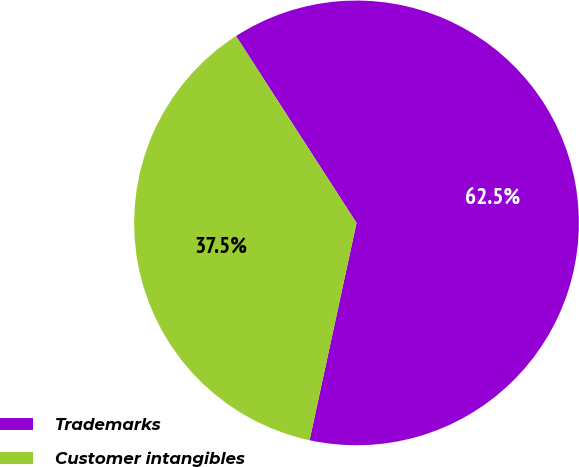Convert chart. <chart><loc_0><loc_0><loc_500><loc_500><pie_chart><fcel>Trademarks<fcel>Customer intangibles<nl><fcel>62.5%<fcel>37.5%<nl></chart> 